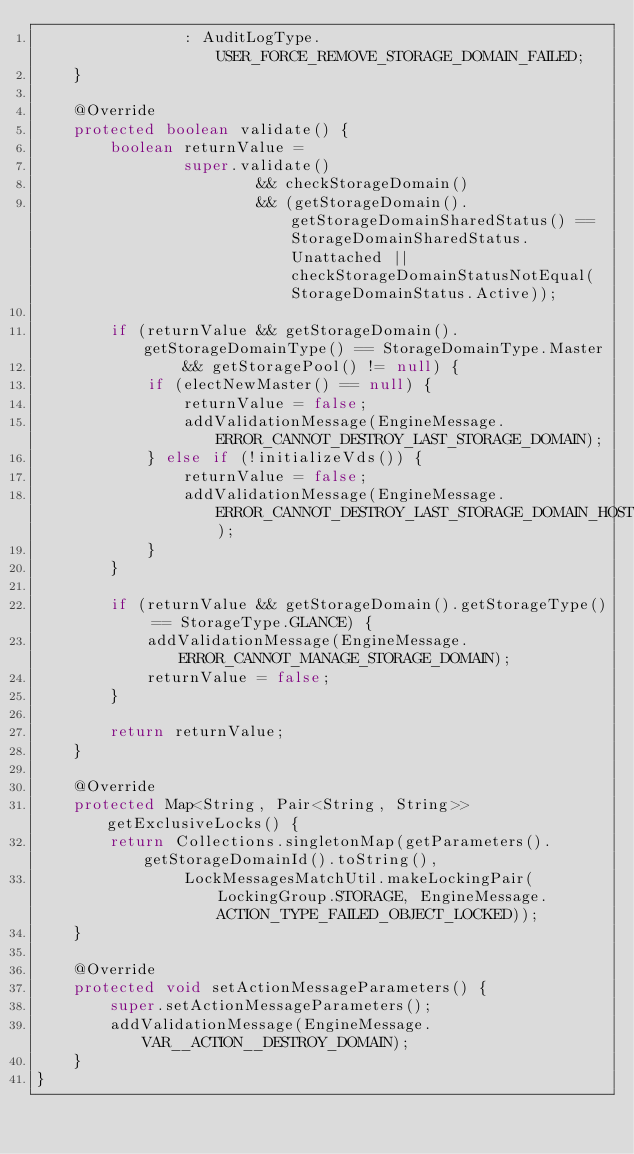Convert code to text. <code><loc_0><loc_0><loc_500><loc_500><_Java_>                : AuditLogType.USER_FORCE_REMOVE_STORAGE_DOMAIN_FAILED;
    }

    @Override
    protected boolean validate() {
        boolean returnValue =
                super.validate()
                        && checkStorageDomain()
                        && (getStorageDomain().getStorageDomainSharedStatus() == StorageDomainSharedStatus.Unattached || checkStorageDomainStatusNotEqual(StorageDomainStatus.Active));

        if (returnValue && getStorageDomain().getStorageDomainType() == StorageDomainType.Master
                && getStoragePool() != null) {
            if (electNewMaster() == null) {
                returnValue = false;
                addValidationMessage(EngineMessage.ERROR_CANNOT_DESTROY_LAST_STORAGE_DOMAIN);
            } else if (!initializeVds()) {
                returnValue = false;
                addValidationMessage(EngineMessage.ERROR_CANNOT_DESTROY_LAST_STORAGE_DOMAIN_HOST_NOT_ACTIVE);
            }
        }

        if (returnValue && getStorageDomain().getStorageType() == StorageType.GLANCE) {
            addValidationMessage(EngineMessage.ERROR_CANNOT_MANAGE_STORAGE_DOMAIN);
            returnValue = false;
        }

        return returnValue;
    }

    @Override
    protected Map<String, Pair<String, String>> getExclusiveLocks() {
        return Collections.singletonMap(getParameters().getStorageDomainId().toString(),
                LockMessagesMatchUtil.makeLockingPair(LockingGroup.STORAGE, EngineMessage.ACTION_TYPE_FAILED_OBJECT_LOCKED));
    }

    @Override
    protected void setActionMessageParameters() {
        super.setActionMessageParameters();
        addValidationMessage(EngineMessage.VAR__ACTION__DESTROY_DOMAIN);
    }
}
</code> 